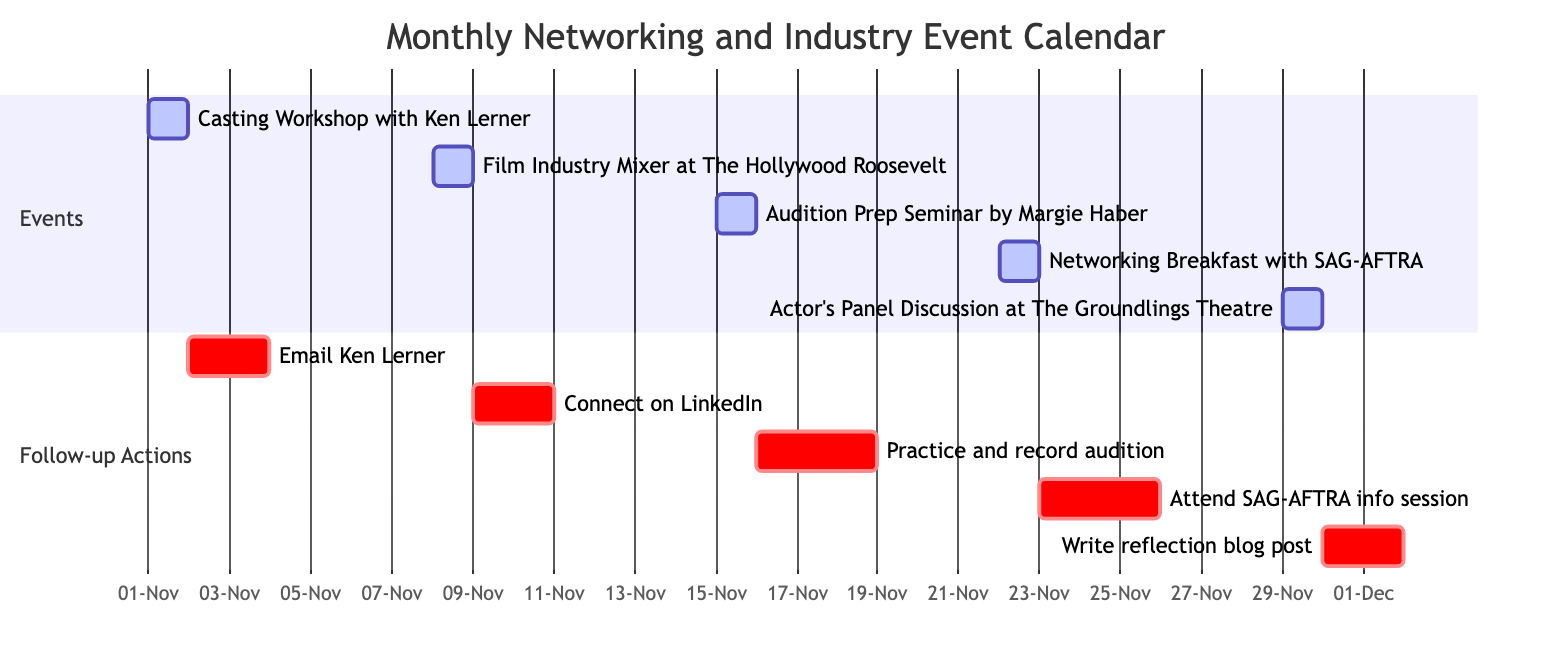What is the date of the Casting Workshop with Ken Lerner? The diagram shows the start date for the Casting Workshop with Ken Lerner as November 1, 2023, which is part of the events section.
Answer: November 1, 2023 How many events are scheduled in November? By counting the different events listed in the events section of the diagram, there are five events in total scheduled for November 2023.
Answer: 5 What is the follow-up action after the Film Industry Mixer? The follow-up action listed in the diagram after the Film Industry Mixer event on November 8, 2023, is to connect on LinkedIn with new contacts made at the event.
Answer: Connect on LinkedIn Which event is followed by the longest follow-up action duration? In examining the follow-up actions, the "Practice and record audition" action after the Audition Prep Seminar has a duration of three days, which is the longest compared to the other follow-up actions specified.
Answer: Practice and record audition What is the last event happening in November? The Actor's Panel Discussion at The Groundlings Theatre is the final event scheduled in November, occurring on November 29, 2023, which makes it the last event of that month.
Answer: Actor's Panel Discussion at The Groundlings Theatre What is the starting date of the Networking Breakfast with SAG-AFTRA? The Networking Breakfast with SAG-AFTRA is depicted in the diagram with a start date of November 22, 2023, indicating when this event will take place.
Answer: November 22, 2023 How many follow-up actions are scheduled for the event on November 15, 2023? Looking at the follow-up actions section, the Audition Prep Seminar has one follow-up action, which is to "Practice and record audition using tips from the seminar."
Answer: 1 What actions are scheduled immediately after the Casting Workshop? The follow-up action for the Casting Workshop is scheduled for November 2, 2023, to email Ken Lerner, making it an immediate action following the workshop.
Answer: Email Ken Lerner 